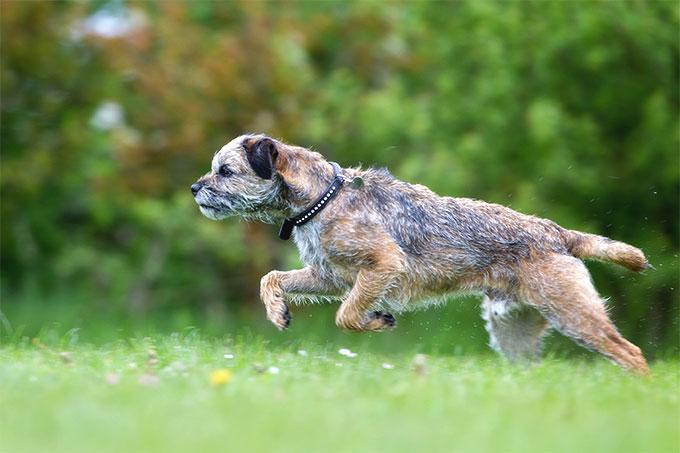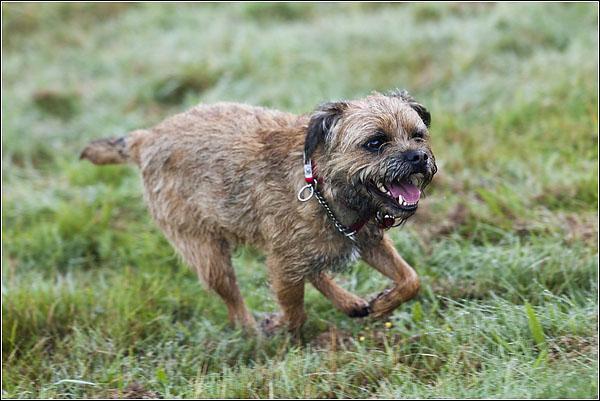The first image is the image on the left, the second image is the image on the right. For the images shown, is this caption "The dog in the image on the right is not running." true? Answer yes or no. No. The first image is the image on the left, the second image is the image on the right. For the images shown, is this caption "Both images show a dog running in the grass." true? Answer yes or no. Yes. 